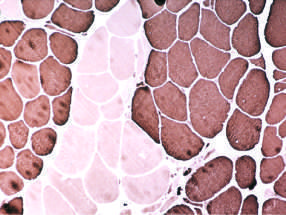what share the same fiber type (fiber type grouping)?
Answer the question using a single word or phrase. Large clusters of fibers 